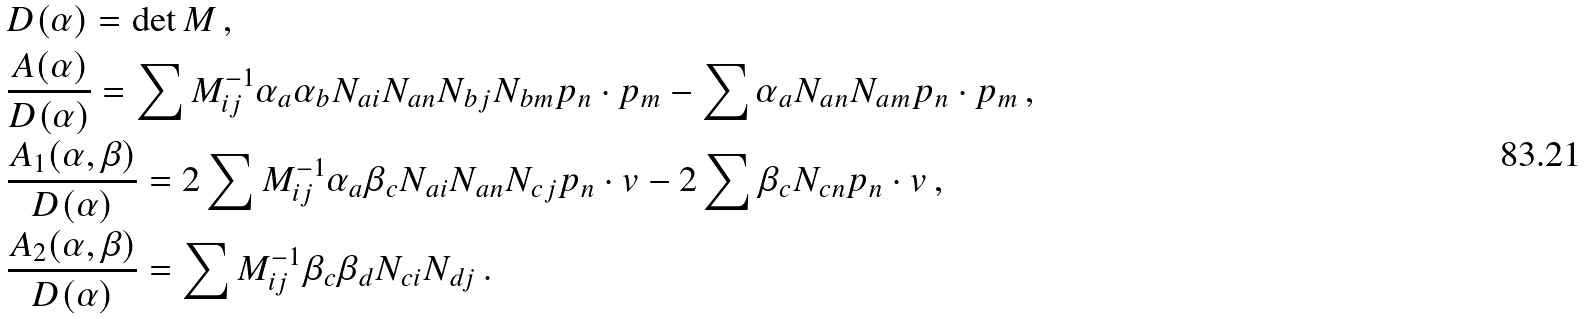<formula> <loc_0><loc_0><loc_500><loc_500>& D ( \alpha ) = \det M \, , \\ & \frac { A ( \alpha ) } { D ( \alpha ) } = \sum M ^ { - 1 } _ { i j } \alpha _ { a } \alpha _ { b } N _ { a i } N _ { a n } N _ { b j } N _ { b m } p _ { n } \cdot p _ { m } - \sum \alpha _ { a } N _ { a n } N _ { a m } p _ { n } \cdot p _ { m } \, , \\ & \frac { A _ { 1 } ( \alpha , \beta ) } { D ( \alpha ) } = 2 \sum M ^ { - 1 } _ { i j } \alpha _ { a } \beta _ { c } N _ { a i } N _ { a n } N _ { c j } p _ { n } \cdot v - 2 \sum \beta _ { c } N _ { c n } p _ { n } \cdot v \, , \\ & \frac { A _ { 2 } ( \alpha , \beta ) } { D ( \alpha ) } = \sum M ^ { - 1 } _ { i j } \beta _ { c } \beta _ { d } N _ { c i } N _ { d j } \, .</formula> 